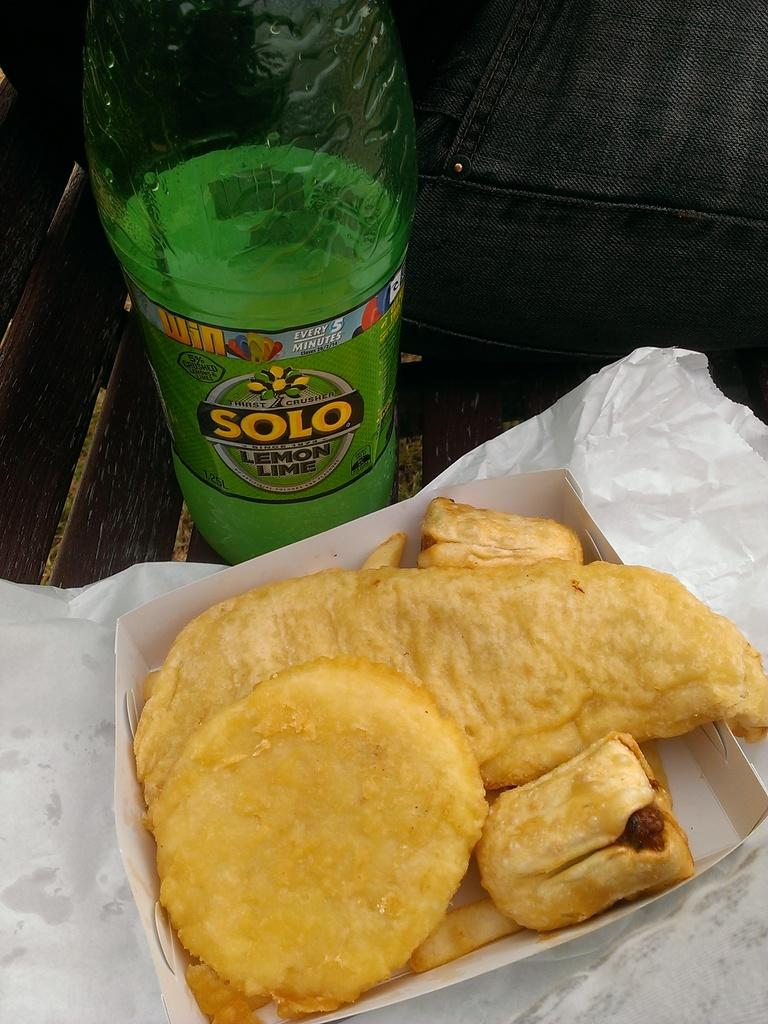What type of bottle can be seen in the image? There is a green color bottle in the image. What other items are present in the image besides the bottle? There is paper, a box, and food in the image. Where are these items located? All of these items are on a bench. Can you see a nest in the image? There is no nest present in the image. What type of unit is being used to store the food in the image? The provided facts do not mention a specific unit for storing the food; it only states that there is food in the image. 